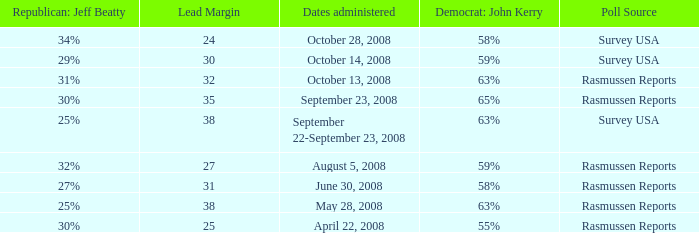What are the dates where democrat john kerry is 63% and poll source is rasmussen reports? October 13, 2008, May 28, 2008. I'm looking to parse the entire table for insights. Could you assist me with that? {'header': ['Republican: Jeff Beatty', 'Lead Margin', 'Dates administered', 'Democrat: John Kerry', 'Poll Source'], 'rows': [['34%', '24', 'October 28, 2008', '58%', 'Survey USA'], ['29%', '30', 'October 14, 2008', '59%', 'Survey USA'], ['31%', '32', 'October 13, 2008', '63%', 'Rasmussen Reports'], ['30%', '35', 'September 23, 2008', '65%', 'Rasmussen Reports'], ['25%', '38', 'September 22-September 23, 2008', '63%', 'Survey USA'], ['32%', '27', 'August 5, 2008', '59%', 'Rasmussen Reports'], ['27%', '31', 'June 30, 2008', '58%', 'Rasmussen Reports'], ['25%', '38', 'May 28, 2008', '63%', 'Rasmussen Reports'], ['30%', '25', 'April 22, 2008', '55%', 'Rasmussen Reports']]} 